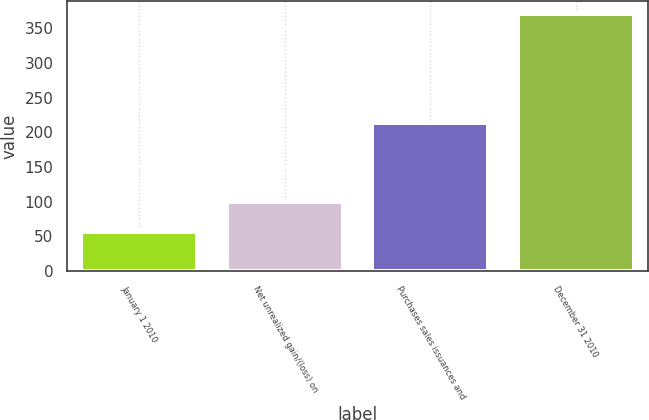Convert chart to OTSL. <chart><loc_0><loc_0><loc_500><loc_500><bar_chart><fcel>January 1 2010<fcel>Net unrealized gain/(loss) on<fcel>Purchases sales issuances and<fcel>December 31 2010<nl><fcel>57<fcel>99<fcel>214<fcel>370<nl></chart> 